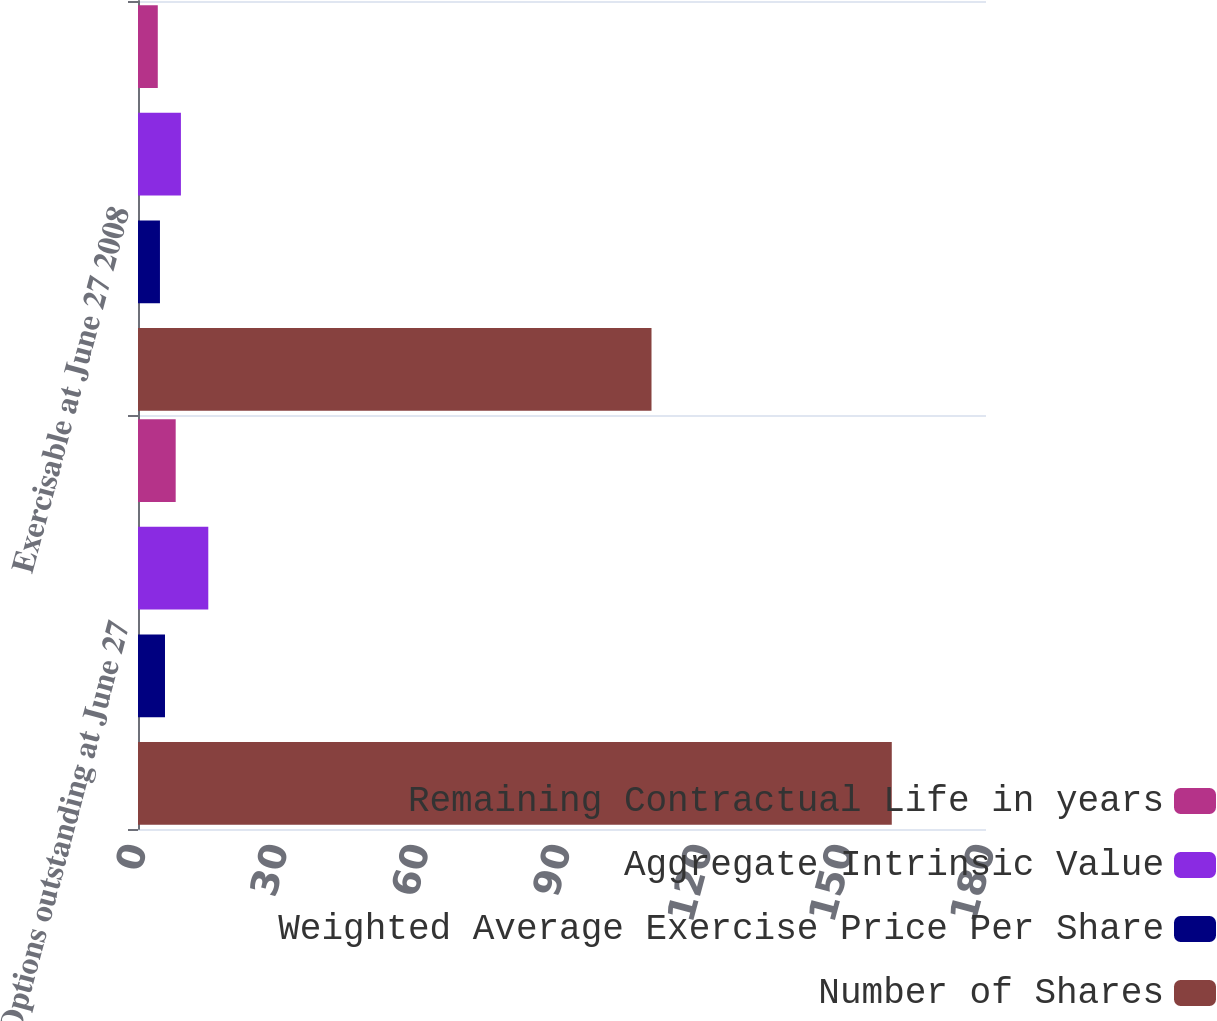Convert chart to OTSL. <chart><loc_0><loc_0><loc_500><loc_500><stacked_bar_chart><ecel><fcel>Options outstanding at June 27<fcel>Exercisable at June 27 2008<nl><fcel>Remaining Contractual Life in years<fcel>8<fcel>4.2<nl><fcel>Aggregate Intrinsic Value<fcel>14.92<fcel>9.11<nl><fcel>Weighted Average Exercise Price Per Share<fcel>5.73<fcel>4.66<nl><fcel>Number of Shares<fcel>160<fcel>109<nl></chart> 